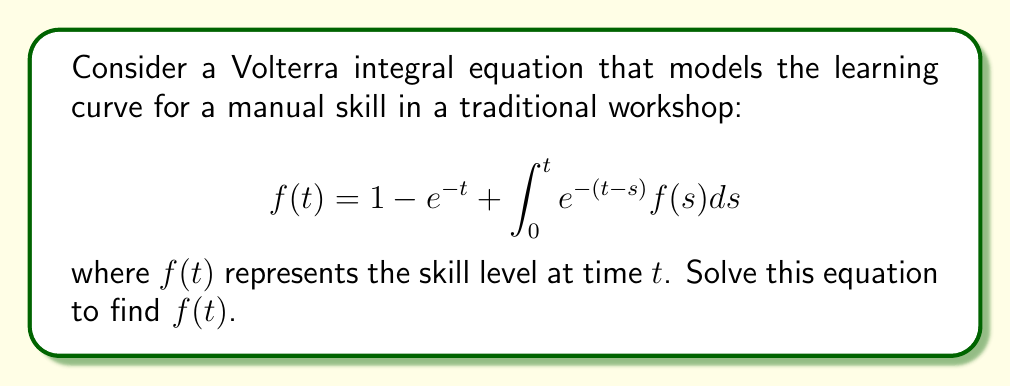Could you help me with this problem? Let's solve this Volterra integral equation step-by-step:

1) First, we differentiate both sides of the equation with respect to $t$:

   $$f'(t) = e^{-t} + e^{-t}f(t) + \int_0^t (-e^{-(t-s)})f(s)ds$$

2) Simplify the right-hand side:

   $$f'(t) = e^{-t} + e^{-t}f(t) - \int_0^t e^{-(t-s)}f(s)ds$$

3) Substitute the original equation for the integral term:

   $$f'(t) = e^{-t} + e^{-t}f(t) - (f(t) - 1 + e^{-t})$$

4) Simplify:

   $$f'(t) = 1$$

5) This is a simple differential equation. Integrate both sides:

   $$f(t) = t + C$$

6) To find $C$, use the initial condition $f(0) = 0$ (as given in the original equation):

   $$0 = 0 + C$$
   $$C = 0$$

7) Therefore, the solution is:

   $$f(t) = t$$

8) Verify by substituting back into the original equation:

   $$t = 1 - e^{-t} + \int_0^t e^{-(t-s)}s ds$$

   The right-hand side simplifies to $t$, confirming our solution.
Answer: $f(t) = t$ 